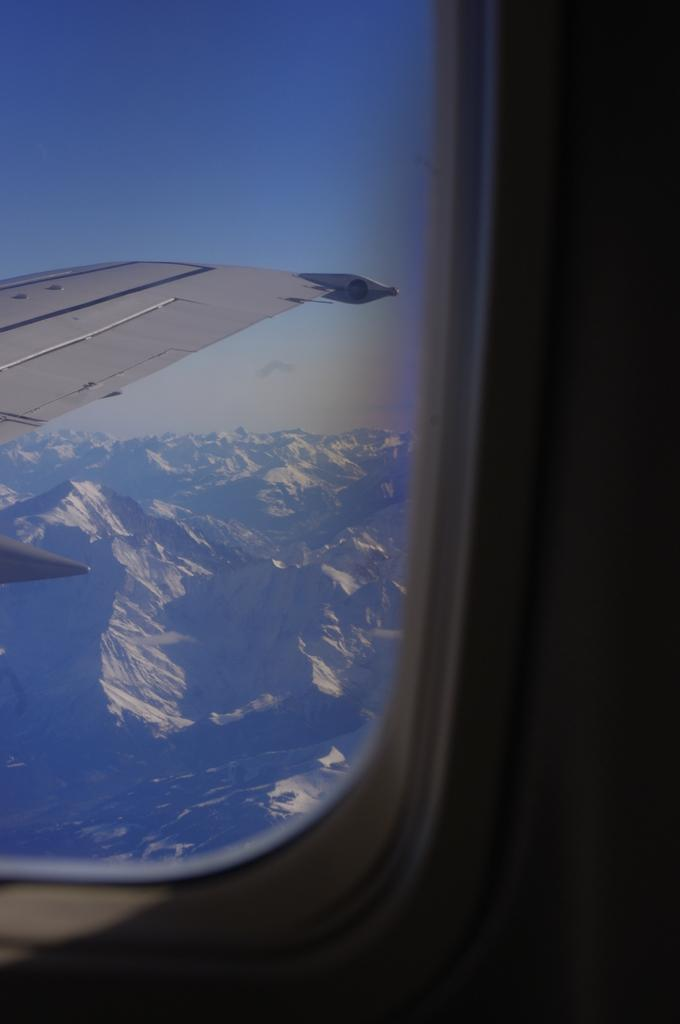What type of location is depicted in the image? The image shows the inside of an aircraft. What part of the aircraft can be seen in the image? There is a part of the aircraft visible in the image. What type of natural landscape is visible in the image? There are mountains in the image. What else can be seen in the image besides the aircraft and mountains? The sky is visible in the image. What type of prose is being read by the passengers in the image? There is no indication in the image that passengers are reading any prose. Can you see a yoke in the image? There is no yoke visible in the image. 